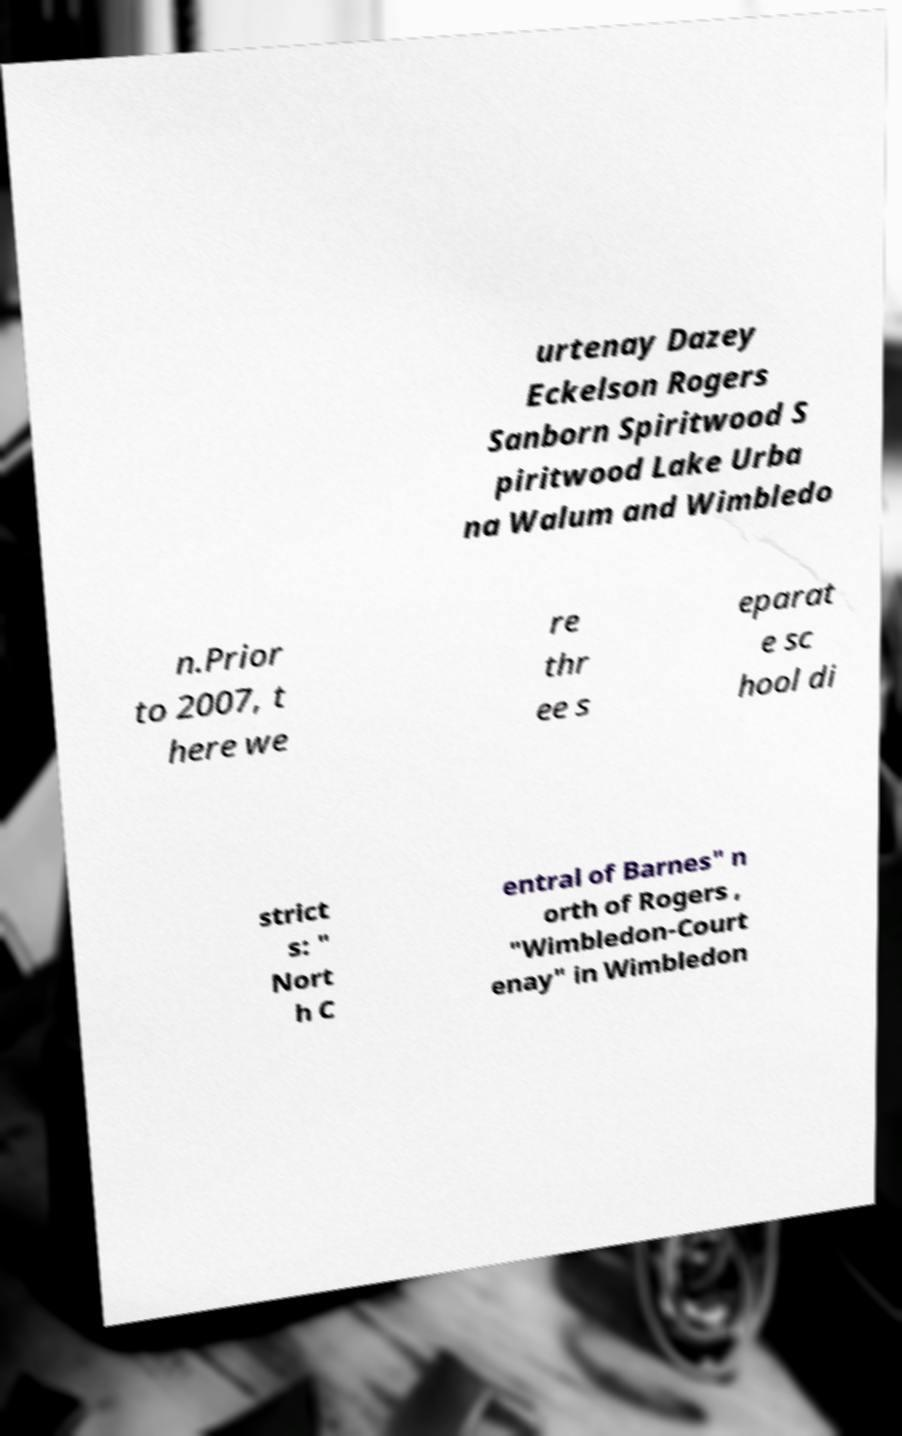Can you accurately transcribe the text from the provided image for me? urtenay Dazey Eckelson Rogers Sanborn Spiritwood S piritwood Lake Urba na Walum and Wimbledo n.Prior to 2007, t here we re thr ee s eparat e sc hool di strict s: " Nort h C entral of Barnes" n orth of Rogers , "Wimbledon-Court enay" in Wimbledon 